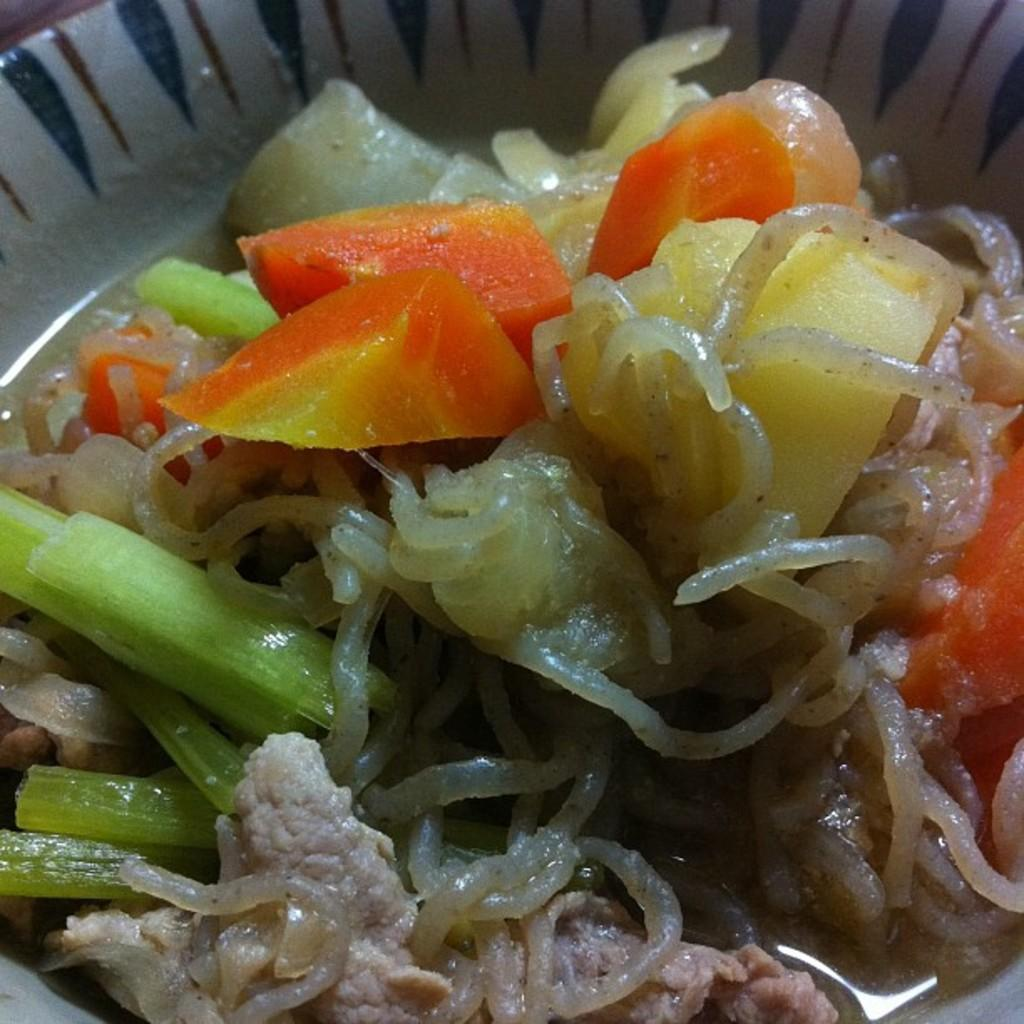What is present in the image related to food? There is food in the image. How is the food arranged or displayed in the image? The food is in a plate. Where is the plate with food located in the image? The plate is in the center of the image. What type of cake is being carried by the person walking in the image? There is no person walking or cake present in the image. 